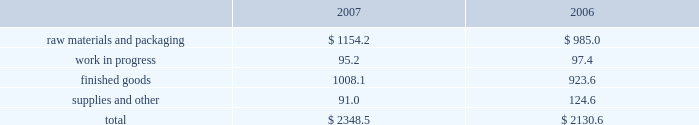Notes to consolidated financial statements 2014 ( continued ) fiscal years ended may 27 , 2007 , may 28 , 2006 , and may 29 , 2005 columnar amounts in millions except per share amounts 6 .
Impairment of debt and equity securities during fiscal 2005 , the company determined that the carrying values of its investments in two unrelated equity method investments , a bio-fuels venture and a malt venture , were other-than-temporarily impaired and therefore recognized pre-tax impairment charges totaling $ 71.0 million ( $ 65.6 million after tax ) .
During fiscal 2006 , the company recognized additional impairment charges totaling $ 75.8 million ( $ 73.1 million after tax ) of its investments in the malt venture and an unrelated investment in a foreign prepared foods business , due to further declines in the estimated proceeds from the disposition of these investments .
The investment in a foreign prepared foods business was disposed of in fiscal 2006 .
The extent of the impairments was determined based upon the company 2019s assessment of the recoverability of its investments based primarily upon the expected proceeds of planned dispositions of the investments .
During fiscal 2007 , the company completed the disposition of the equity method investment in the malt venture for proceeds of approximately $ 24 million , including notes and other receivables totaling approximately $ 7 million .
This transaction resulted in a pre-tax gain of approximately $ 4 million , with a related tax benefit of approximately $ 4 million .
These charges and the subsequent gain on disposition are reflected in equity method investment earnings ( loss ) in the consolidated statements of earnings .
The company held , at may 28 , 2006 , subordinated notes in the original principal amount of $ 150 million plus accrued interest of $ 50.4 million from swift foods .
During the company 2019s fourth quarter of fiscal 2005 , swift foods effected changes in its capital structure .
As a result of those changes , the company determined that the fair value of the subordinated notes was impaired .
From the date on which the company initially determined that the value of the notes was impaired through the second quarter of fiscal 2006 , the company believed the impairment of this available-for-sale security to be temporary .
As such , the company had reduced the carrying value of the note by $ 35.4 million and recorded cumulative after-tax charges of $ 21.9 million in accumulated other comprehensive income as of the end of the second quarter of fiscal 2006 .
During the second half of fiscal 2006 , due to the company 2019s consideration of current conditions related to the debtor 2019s business and changes in the company 2019s intended holding period for this investment , the company determined that the impairment was other-than-temporary .
Accordingly , the company reduced the carrying value of the notes to approximately $ 117 million and recognized impairment charges totaling $ 82.9 million in selling , general and administrative expenses , including the reclassification of the cumulative after-tax charges of $ 21.9 million from accumulated other comprehensive income , in fiscal 2006 .
During the second quarter of fiscal 2007 , the company closed on the sale of these notes for approximately $ 117 million , net of transaction expenses , resulting in no additional gain or loss .
Inventories the major classes of inventories are as follows: .
Raw materials and packaging includes grain , fertilizer , crude oil , and other trading and merchandising inventory of $ 691.0 million and $ 542.1 million as of the end of fiscal year 2007 and 2006 , respectively. .
What percent of total inventories was comprised of raw materials and packaging in 2006? 
Computations: (985.0 / 2130.6)
Answer: 0.46231. 